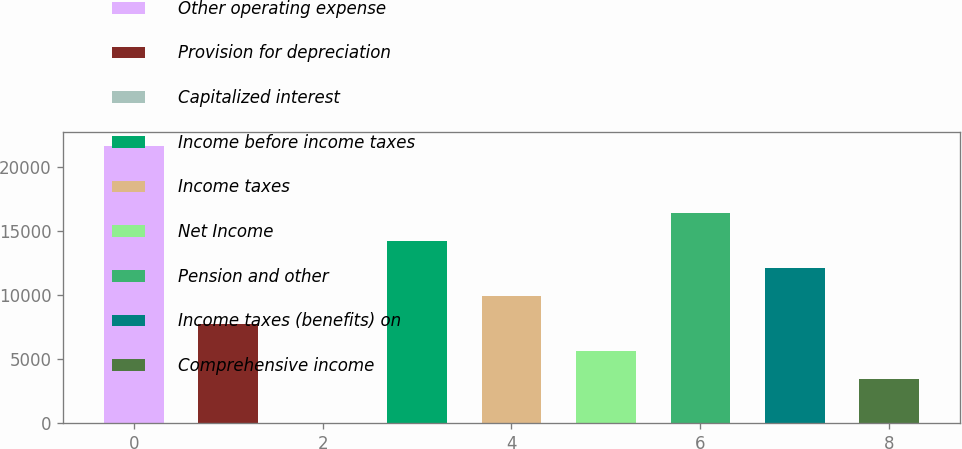Convert chart. <chart><loc_0><loc_0><loc_500><loc_500><bar_chart><fcel>Other operating expense<fcel>Provision for depreciation<fcel>Capitalized interest<fcel>Income before income taxes<fcel>Income taxes<fcel>Net Income<fcel>Pension and other<fcel>Income taxes (benefits) on<fcel>Comprehensive income<nl><fcel>21648<fcel>7767.6<fcel>20<fcel>14256<fcel>9930.4<fcel>5604.8<fcel>16418.8<fcel>12093.2<fcel>3442<nl></chart> 